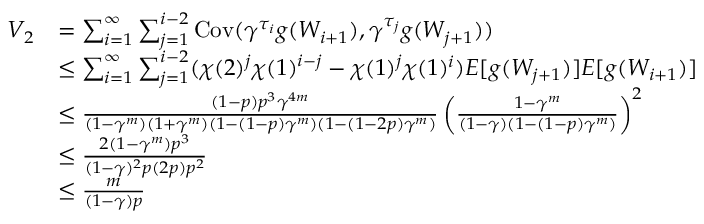<formula> <loc_0><loc_0><loc_500><loc_500>\begin{array} { r l } { V _ { 2 } } & { = \sum _ { i = 1 } ^ { \infty } \sum _ { j = 1 } ^ { i - 2 } C o v ( \gamma ^ { \tau _ { i } } g ( W _ { i + 1 } ) , \gamma ^ { \tau _ { j } } g ( W _ { j + 1 } ) ) } \\ & { \leq \sum _ { i = 1 } ^ { \infty } \sum _ { j = 1 } ^ { i - 2 } ( \chi ( 2 ) ^ { j } \chi ( 1 ) ^ { i - j } - \chi ( 1 ) ^ { j } \chi ( 1 ) ^ { i } ) E [ g ( W _ { j + 1 } ) ] E [ g ( W _ { i + 1 } ) ] } \\ & { \leq \frac { ( 1 - p ) p ^ { 3 } \gamma ^ { 4 m } } { ( 1 - \gamma ^ { m } ) ( 1 + \gamma ^ { m } ) ( 1 - ( 1 - p ) \gamma ^ { m } ) ( 1 - ( 1 - 2 p ) \gamma ^ { m } ) } \left ( \frac { 1 - \gamma ^ { m } } { ( 1 - \gamma ) ( 1 - ( 1 - p ) \gamma ^ { m } ) } \right ) ^ { 2 } } \\ & { \leq \frac { 2 ( 1 - \gamma ^ { m } ) p ^ { 3 } } { ( 1 - \gamma ) ^ { 2 } p ( 2 p ) p ^ { 2 } } } \\ & { \leq \frac { m } { ( 1 - \gamma ) p } } \end{array}</formula> 